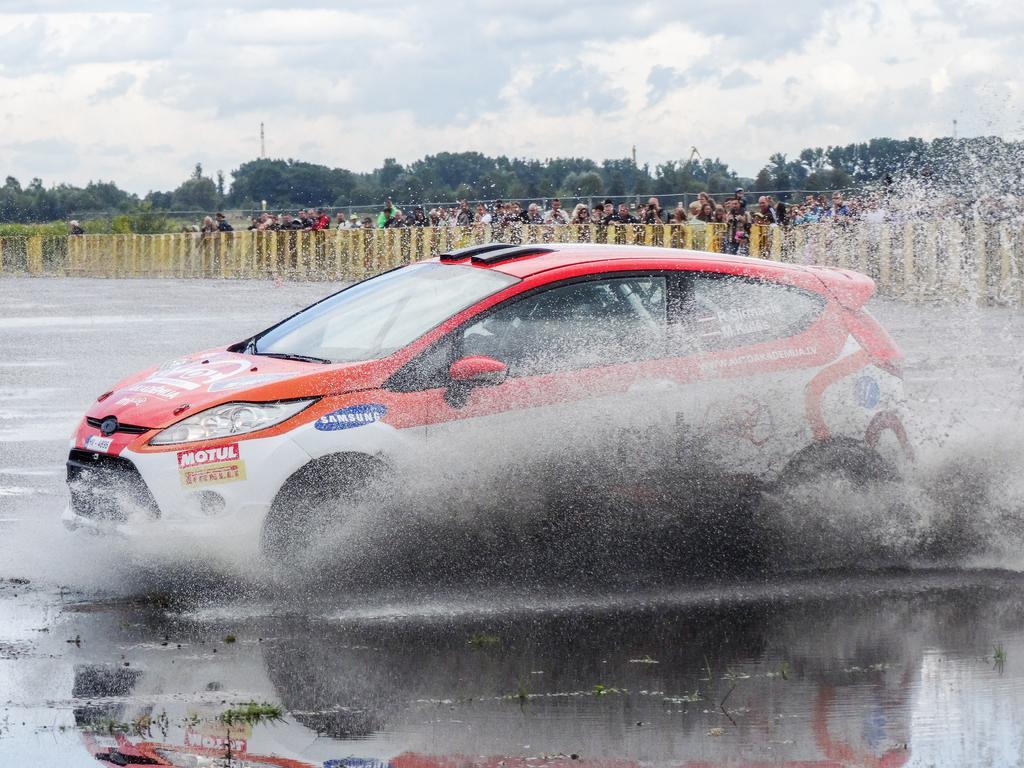In one or two sentences, can you explain what this image depicts? In the picture I can see the sports car on the road and there is a water on the road. I can see a group of people standing on the road and I can see the barricades on the road. In the background, I can see the trees. There are clouds in the sky. 